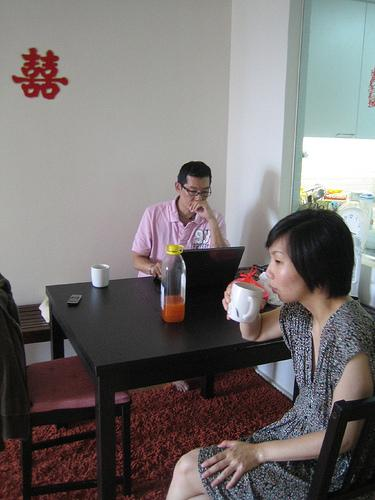Why is the woman blowing on the mug?

Choices:
A) to cool
B) to inflate
C) to move
D) to spin to cool 